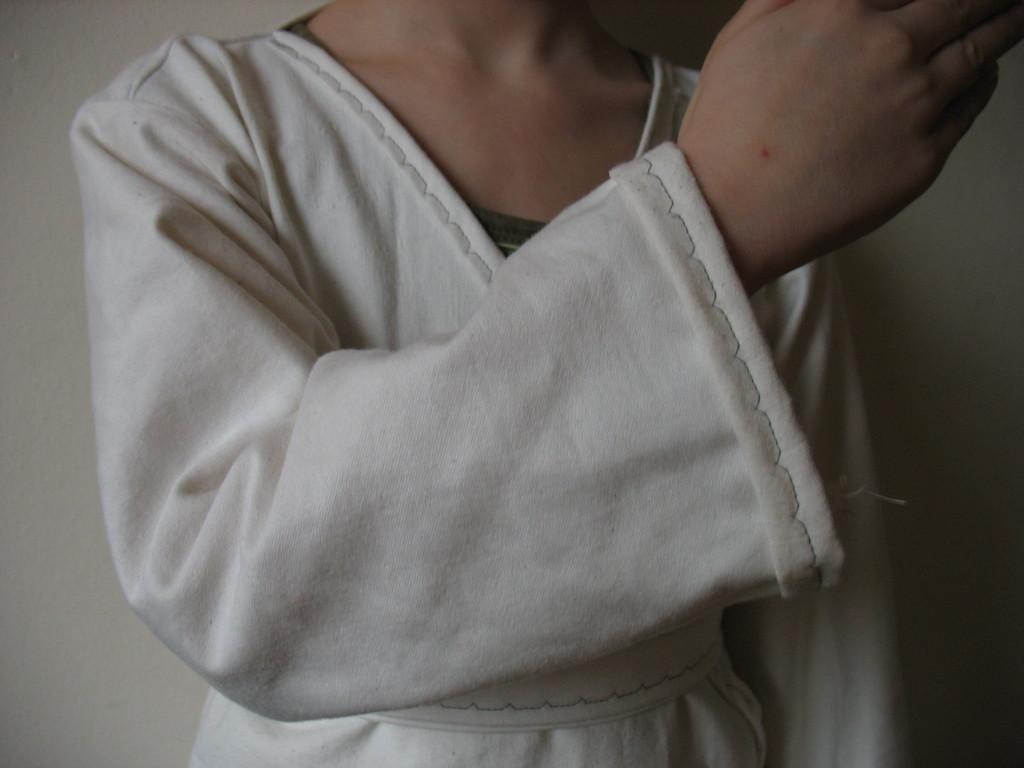How would you summarize this image in a sentence or two? In this image I can see the person with white color dress. And there is a white background. 